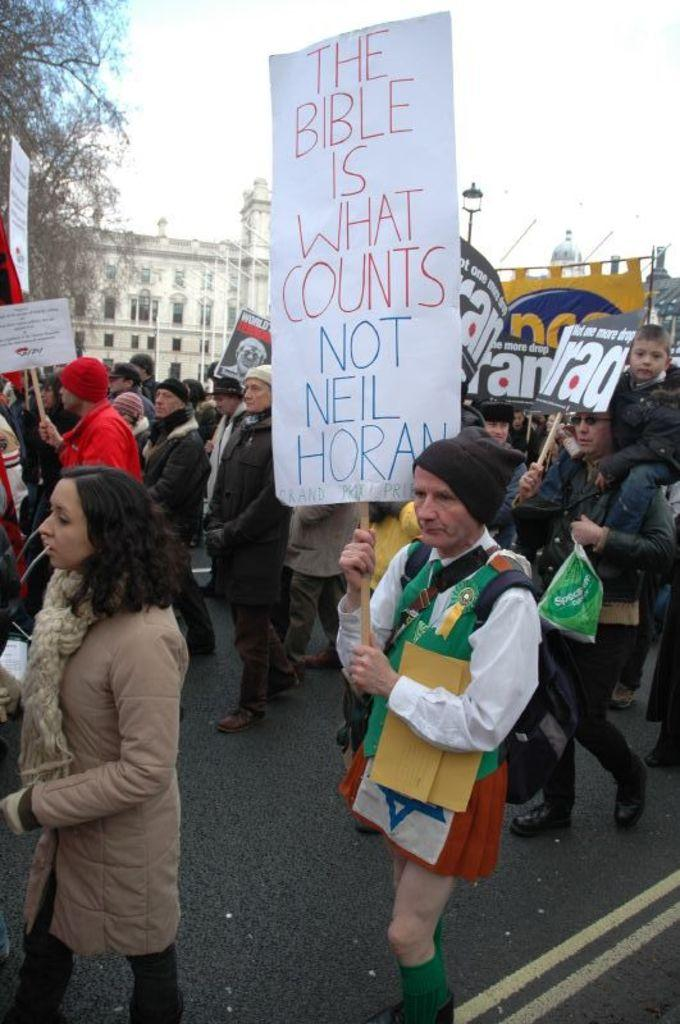How many people are in the image? There is a group of people in the image, but the exact number is not specified. Where are the people located in the image? The people are on the road in the image. What are the people holding in the image? The people are holding boards in the image. What can be seen in the background of the image? There are buildings, branches, a pole, a light, and the sky visible in the background of the image. What type of silk is being used to create the letters on the boards in the image? There is no silk or letters present on the boards in the image. The boards are held by the people, but their content is not specified. 